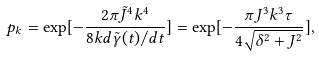Convert formula to latex. <formula><loc_0><loc_0><loc_500><loc_500>p _ { k } = \exp [ - \frac { 2 \pi \tilde { J } ^ { 4 } k ^ { 4 } } { 8 k d \tilde { \gamma } ( t ) / d t } ] = \exp [ - \frac { \pi J ^ { 3 } k ^ { 3 } \tau } { 4 \sqrt { \delta ^ { 2 } + J ^ { 2 } } } ] ,</formula> 